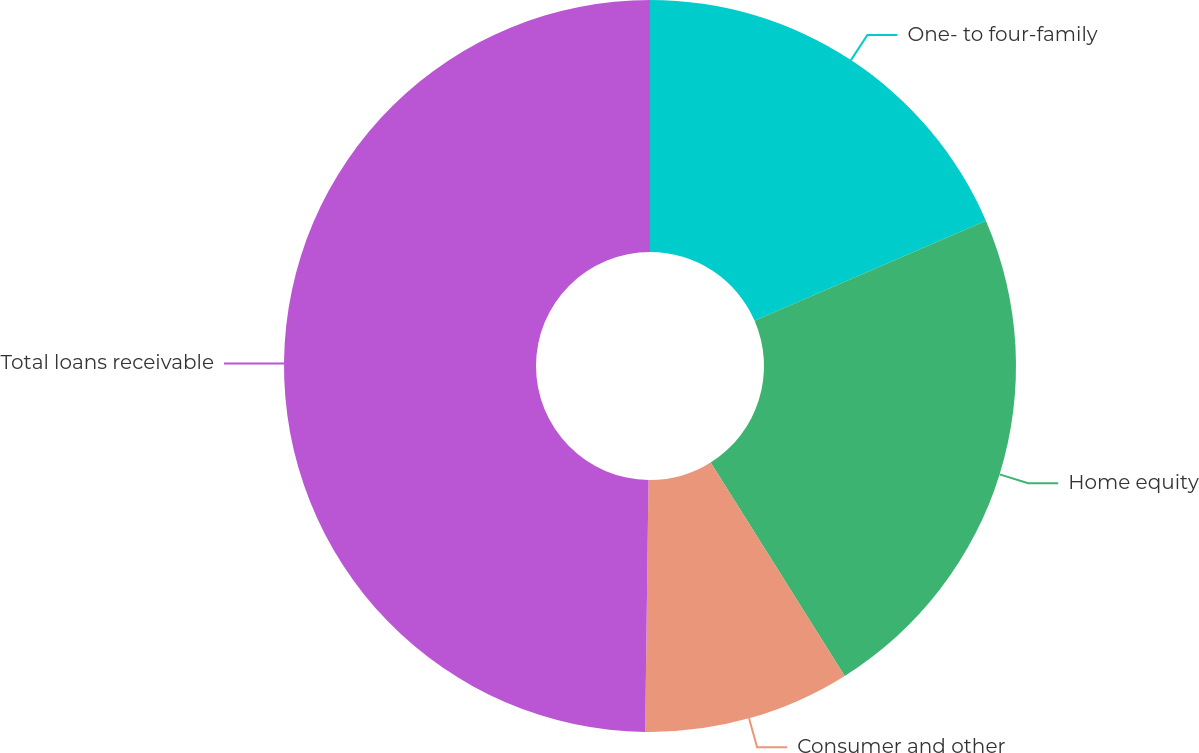Convert chart. <chart><loc_0><loc_0><loc_500><loc_500><pie_chart><fcel>One- to four-family<fcel>Home equity<fcel>Consumer and other<fcel>Total loans receivable<nl><fcel>18.5%<fcel>22.57%<fcel>9.14%<fcel>49.79%<nl></chart> 